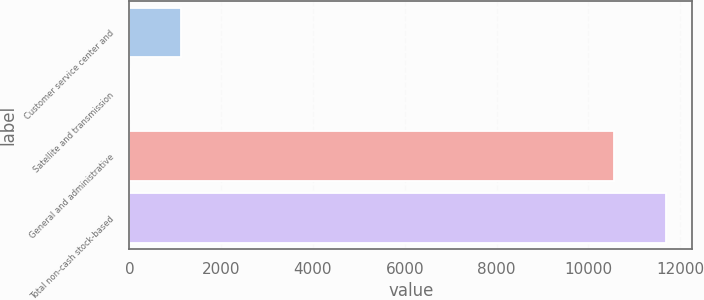Convert chart. <chart><loc_0><loc_0><loc_500><loc_500><bar_chart><fcel>Customer service center and<fcel>Satellite and transmission<fcel>General and administrative<fcel>Total non-cash stock-based<nl><fcel>1134.2<fcel>7<fcel>10557<fcel>11684.2<nl></chart> 